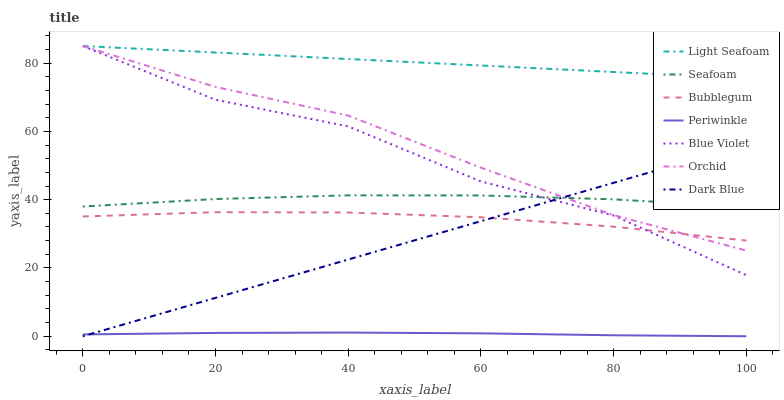Does Periwinkle have the minimum area under the curve?
Answer yes or no. Yes. Does Light Seafoam have the maximum area under the curve?
Answer yes or no. Yes. Does Bubblegum have the minimum area under the curve?
Answer yes or no. No. Does Bubblegum have the maximum area under the curve?
Answer yes or no. No. Is Dark Blue the smoothest?
Answer yes or no. Yes. Is Blue Violet the roughest?
Answer yes or no. Yes. Is Bubblegum the smoothest?
Answer yes or no. No. Is Bubblegum the roughest?
Answer yes or no. No. Does Dark Blue have the lowest value?
Answer yes or no. Yes. Does Bubblegum have the lowest value?
Answer yes or no. No. Does Orchid have the highest value?
Answer yes or no. Yes. Does Bubblegum have the highest value?
Answer yes or no. No. Is Seafoam less than Light Seafoam?
Answer yes or no. Yes. Is Bubblegum greater than Periwinkle?
Answer yes or no. Yes. Does Blue Violet intersect Orchid?
Answer yes or no. Yes. Is Blue Violet less than Orchid?
Answer yes or no. No. Is Blue Violet greater than Orchid?
Answer yes or no. No. Does Seafoam intersect Light Seafoam?
Answer yes or no. No. 